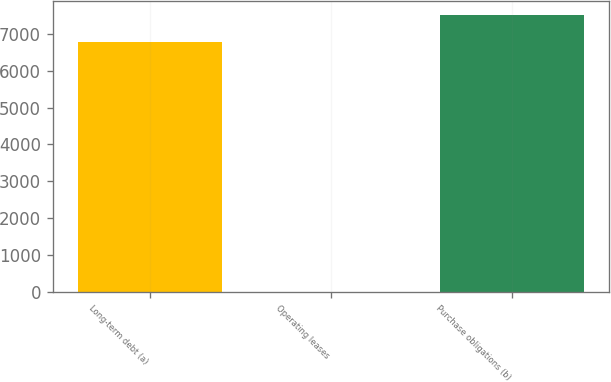Convert chart. <chart><loc_0><loc_0><loc_500><loc_500><bar_chart><fcel>Long-term debt (a)<fcel>Operating leases<fcel>Purchase obligations (b)<nl><fcel>6785<fcel>19<fcel>7495.6<nl></chart> 